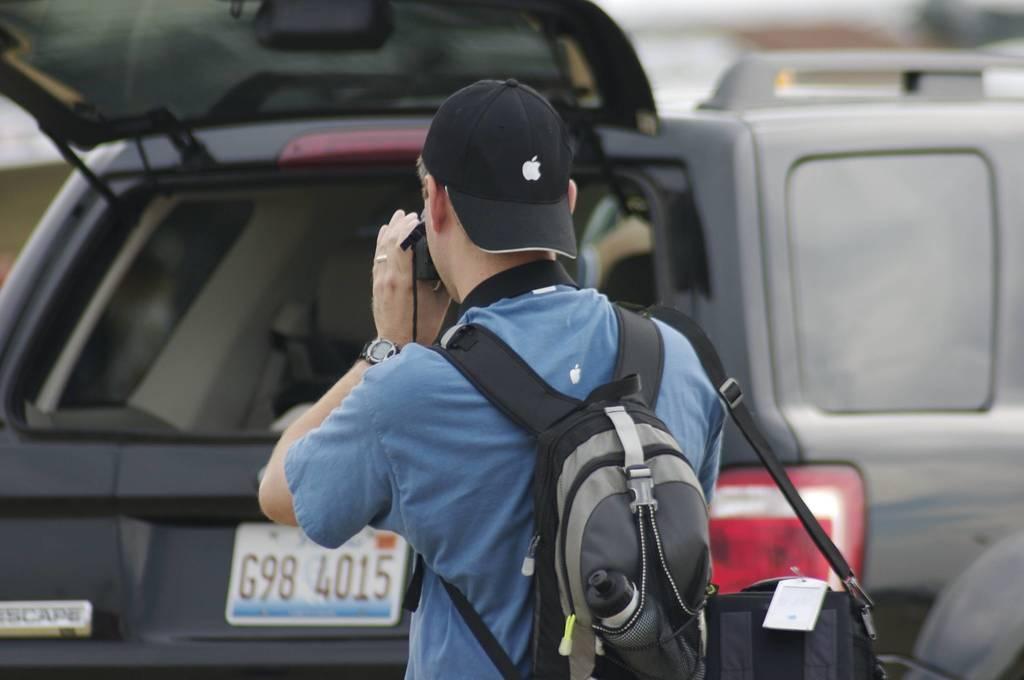Could you give a brief overview of what you see in this image? In this image there is a man with a hat and a bag and he is holding a camera. In the background there are vehicles visible. 